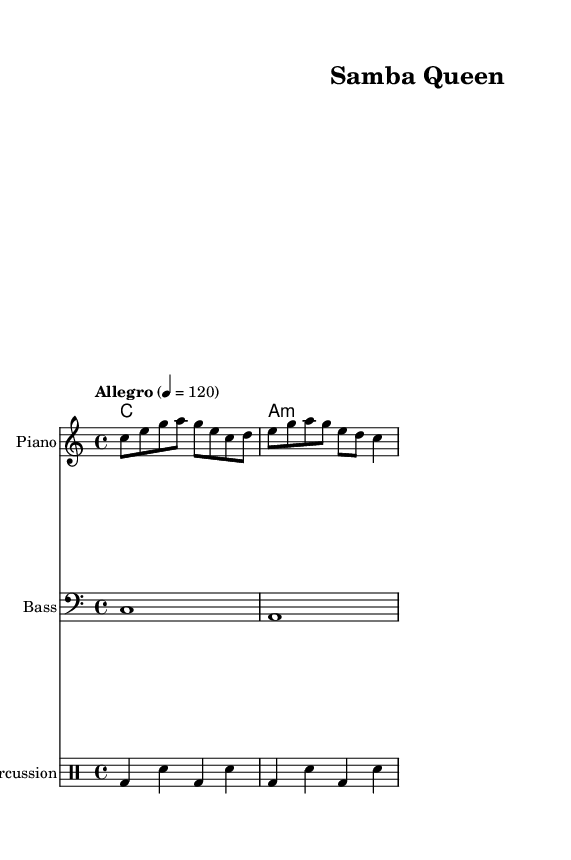What is the key signature of this music? The key signature is C major, which has no sharps or flats.
Answer: C major What is the time signature of this piece? The time signature is found near the beginning of the sheet music, and it shows four beats per measure.
Answer: 4/4 What is the tempo marking indicated in the score? The tempo marking indicates "Allegro" with a speed of 120 beats per minute as shown in the top part of the score.
Answer: Allegro, 120 What is the first note of the melody? The melody starts with the note C, which is indicated at the beginning of the melody line.
Answer: C What chord is played in the harmonies section? The harmonies section shows a chord marked as "C" for the first measure and "A minor" for the next, combining major and minor chords.
Answer: C, A minor How many measures are there in the melody? The melody section is made up of four measures visible from the rhythmic notation, which counts each measure in sequence.
Answer: 4 What type of dance music does this piece represent? The title "Samba Queen" implies that this piece is an upbeat samba, a style of Brazilian music often associated with dance.
Answer: Samba 